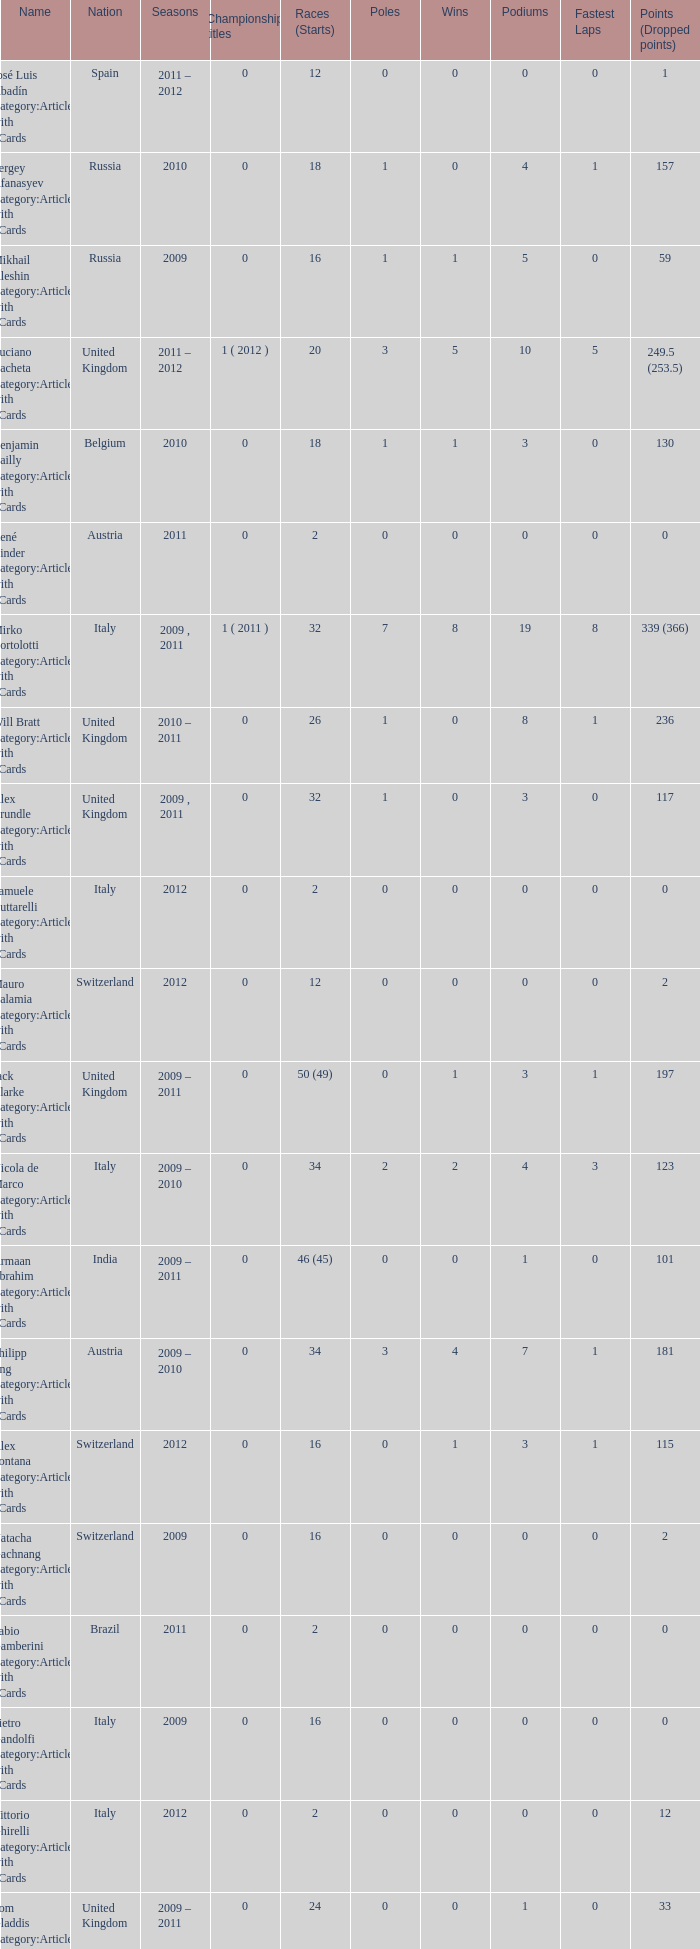What were the starts when the points dropped 18? 8.0. 